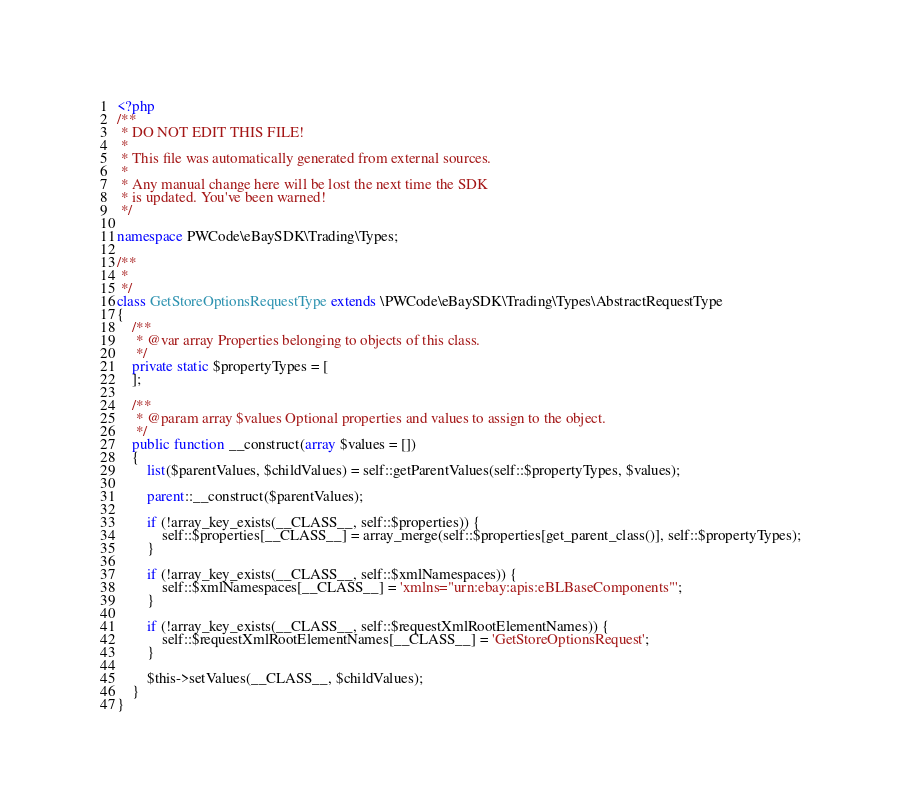Convert code to text. <code><loc_0><loc_0><loc_500><loc_500><_PHP_><?php
/**
 * DO NOT EDIT THIS FILE!
 *
 * This file was automatically generated from external sources.
 *
 * Any manual change here will be lost the next time the SDK
 * is updated. You've been warned!
 */

namespace PWCode\eBaySDK\Trading\Types;

/**
 *
 */
class GetStoreOptionsRequestType extends \PWCode\eBaySDK\Trading\Types\AbstractRequestType
{
    /**
     * @var array Properties belonging to objects of this class.
     */
    private static $propertyTypes = [
    ];

    /**
     * @param array $values Optional properties and values to assign to the object.
     */
    public function __construct(array $values = [])
    {
        list($parentValues, $childValues) = self::getParentValues(self::$propertyTypes, $values);

        parent::__construct($parentValues);

        if (!array_key_exists(__CLASS__, self::$properties)) {
            self::$properties[__CLASS__] = array_merge(self::$properties[get_parent_class()], self::$propertyTypes);
        }

        if (!array_key_exists(__CLASS__, self::$xmlNamespaces)) {
            self::$xmlNamespaces[__CLASS__] = 'xmlns="urn:ebay:apis:eBLBaseComponents"';
        }

        if (!array_key_exists(__CLASS__, self::$requestXmlRootElementNames)) {
            self::$requestXmlRootElementNames[__CLASS__] = 'GetStoreOptionsRequest';
        }

        $this->setValues(__CLASS__, $childValues);
    }
}
</code> 